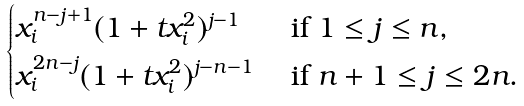Convert formula to latex. <formula><loc_0><loc_0><loc_500><loc_500>\begin{cases} x _ { i } ^ { n - j + 1 } ( 1 + t x _ { i } ^ { 2 } ) ^ { j - 1 } & \text { if $1\leq j\leq n$,} \\ x _ { i } ^ { 2 n - j } ( 1 + t x _ { i } ^ { 2 } ) ^ { j - n - 1 } & \text { if $n+1\leq j\leq 2n$.} \end{cases}</formula> 